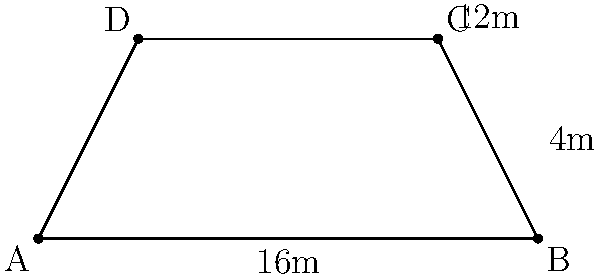At Oxford United's Kassam Stadium, there's a trapezoid-shaped seating section as shown in the diagram. If the parallel sides of the trapezoid measure 16m and 12m, and the height of the trapezoid is 4m, what is the total area of this seating section in square meters? To find the area of a trapezoid, we use the formula:

$$A = \frac{1}{2}(b_1 + b_2)h$$

Where:
$A$ = Area
$b_1$ = Length of one parallel side
$b_2$ = Length of the other parallel side
$h$ = Height (perpendicular distance between the parallel sides)

Given:
$b_1 = 16$ m
$b_2 = 12$ m
$h = 4$ m

Let's substitute these values into the formula:

$$A = \frac{1}{2}(16 + 12) \times 4$$

$$A = \frac{1}{2}(28) \times 4$$

$$A = 14 \times 4$$

$$A = 56$$

Therefore, the area of the trapezoid-shaped seating section is 56 square meters.
Answer: 56 m² 